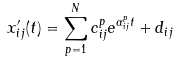<formula> <loc_0><loc_0><loc_500><loc_500>x ^ { \prime } _ { i j } ( t ) = \sum _ { p = 1 } ^ { N } c ^ { p } _ { i j } e ^ { \alpha ^ { p } _ { i j } t } + d _ { i j }</formula> 